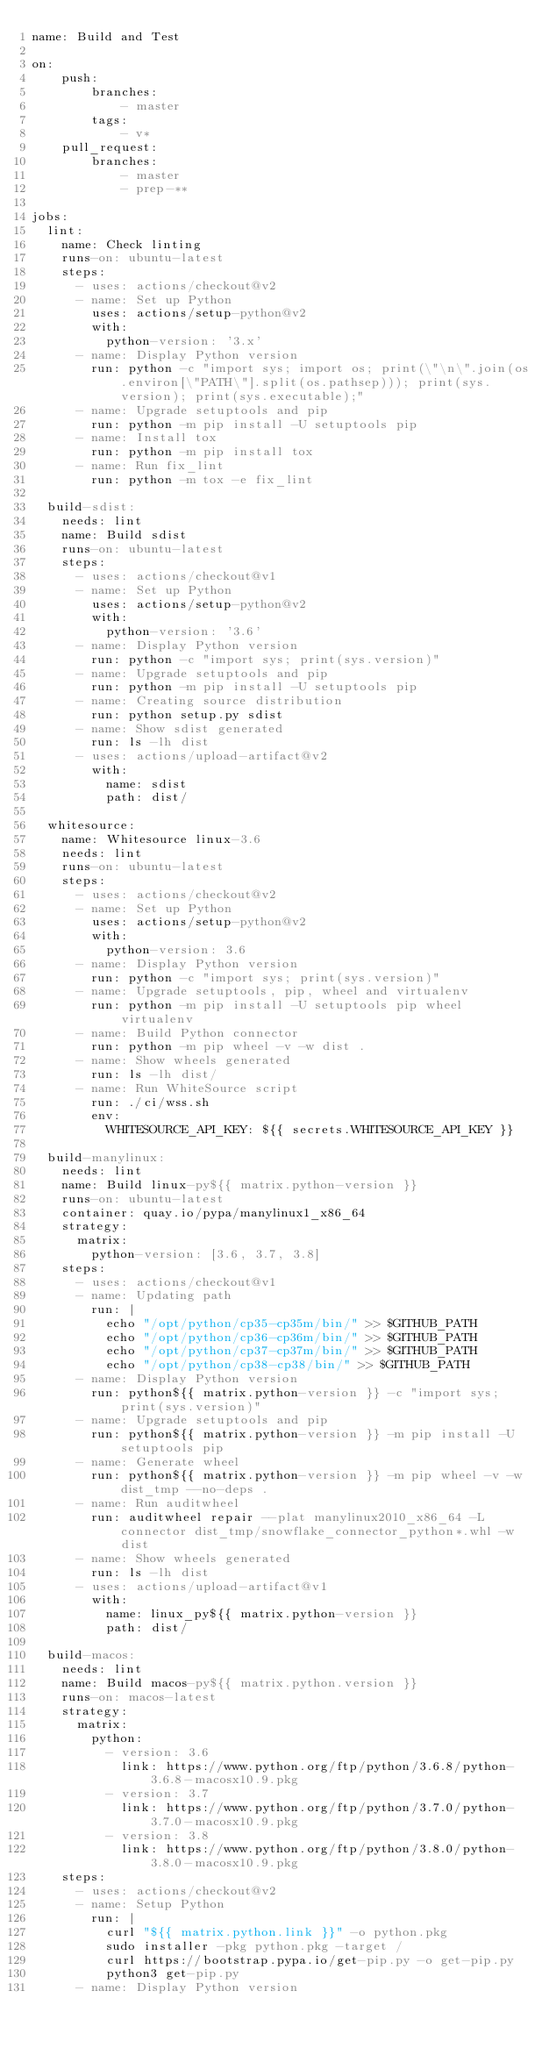<code> <loc_0><loc_0><loc_500><loc_500><_YAML_>name: Build and Test

on:
    push:
        branches:
            - master
        tags:
            - v*
    pull_request:
        branches:
            - master
            - prep-**

jobs:
  lint:
    name: Check linting
    runs-on: ubuntu-latest
    steps:
      - uses: actions/checkout@v2
      - name: Set up Python
        uses: actions/setup-python@v2
        with:
          python-version: '3.x'
      - name: Display Python version
        run: python -c "import sys; import os; print(\"\n\".join(os.environ[\"PATH\"].split(os.pathsep))); print(sys.version); print(sys.executable);"
      - name: Upgrade setuptools and pip
        run: python -m pip install -U setuptools pip
      - name: Install tox
        run: python -m pip install tox
      - name: Run fix_lint
        run: python -m tox -e fix_lint

  build-sdist:
    needs: lint
    name: Build sdist
    runs-on: ubuntu-latest
    steps:
      - uses: actions/checkout@v1
      - name: Set up Python
        uses: actions/setup-python@v2
        with:
          python-version: '3.6'
      - name: Display Python version
        run: python -c "import sys; print(sys.version)"
      - name: Upgrade setuptools and pip
        run: python -m pip install -U setuptools pip
      - name: Creating source distribution
        run: python setup.py sdist
      - name: Show sdist generated
        run: ls -lh dist
      - uses: actions/upload-artifact@v2
        with:
          name: sdist
          path: dist/

  whitesource:
    name: Whitesource linux-3.6
    needs: lint
    runs-on: ubuntu-latest
    steps:
      - uses: actions/checkout@v2
      - name: Set up Python
        uses: actions/setup-python@v2
        with:
          python-version: 3.6
      - name: Display Python version
        run: python -c "import sys; print(sys.version)"
      - name: Upgrade setuptools, pip, wheel and virtualenv
        run: python -m pip install -U setuptools pip wheel virtualenv
      - name: Build Python connector
        run: python -m pip wheel -v -w dist .
      - name: Show wheels generated
        run: ls -lh dist/
      - name: Run WhiteSource script
        run: ./ci/wss.sh
        env:
          WHITESOURCE_API_KEY: ${{ secrets.WHITESOURCE_API_KEY }}

  build-manylinux:
    needs: lint
    name: Build linux-py${{ matrix.python-version }}
    runs-on: ubuntu-latest
    container: quay.io/pypa/manylinux1_x86_64
    strategy:
      matrix:
        python-version: [3.6, 3.7, 3.8]
    steps:
      - uses: actions/checkout@v1
      - name: Updating path
        run: |
          echo "/opt/python/cp35-cp35m/bin/" >> $GITHUB_PATH
          echo "/opt/python/cp36-cp36m/bin/" >> $GITHUB_PATH
          echo "/opt/python/cp37-cp37m/bin/" >> $GITHUB_PATH
          echo "/opt/python/cp38-cp38/bin/" >> $GITHUB_PATH
      - name: Display Python version
        run: python${{ matrix.python-version }} -c "import sys; print(sys.version)"
      - name: Upgrade setuptools and pip
        run: python${{ matrix.python-version }} -m pip install -U setuptools pip
      - name: Generate wheel
        run: python${{ matrix.python-version }} -m pip wheel -v -w dist_tmp --no-deps .
      - name: Run auditwheel
        run: auditwheel repair --plat manylinux2010_x86_64 -L connector dist_tmp/snowflake_connector_python*.whl -w dist
      - name: Show wheels generated
        run: ls -lh dist
      - uses: actions/upload-artifact@v1
        with:
          name: linux_py${{ matrix.python-version }}
          path: dist/

  build-macos:
    needs: lint
    name: Build macos-py${{ matrix.python.version }}
    runs-on: macos-latest
    strategy:
      matrix:
        python:
          - version: 3.6
            link: https://www.python.org/ftp/python/3.6.8/python-3.6.8-macosx10.9.pkg
          - version: 3.7
            link: https://www.python.org/ftp/python/3.7.0/python-3.7.0-macosx10.9.pkg
          - version: 3.8
            link: https://www.python.org/ftp/python/3.8.0/python-3.8.0-macosx10.9.pkg
    steps:
      - uses: actions/checkout@v2
      - name: Setup Python
        run: |
          curl "${{ matrix.python.link }}" -o python.pkg
          sudo installer -pkg python.pkg -target /
          curl https://bootstrap.pypa.io/get-pip.py -o get-pip.py
          python3 get-pip.py
      - name: Display Python version</code> 